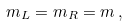Convert formula to latex. <formula><loc_0><loc_0><loc_500><loc_500>m _ { L } = m _ { R } = m \, ,</formula> 